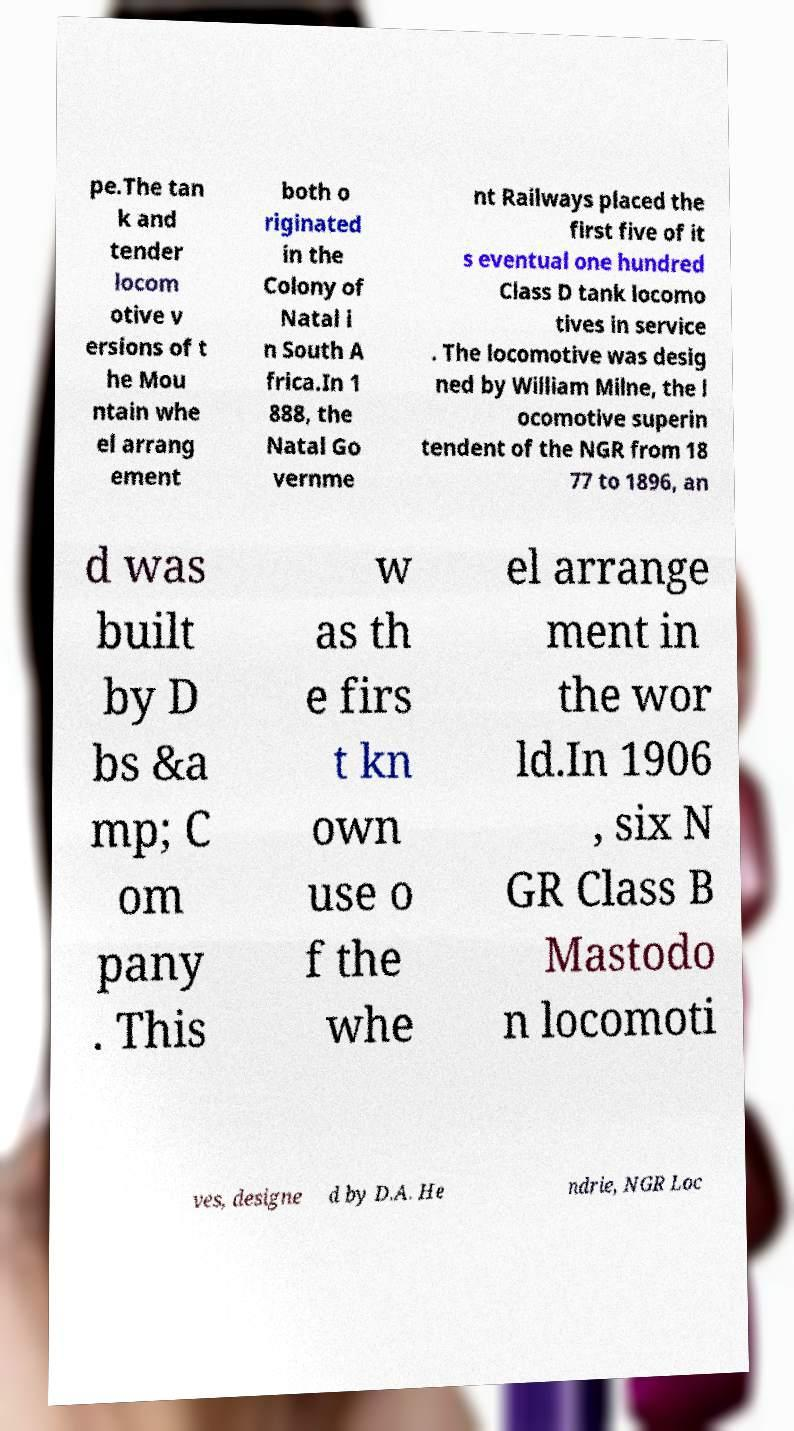Could you assist in decoding the text presented in this image and type it out clearly? pe.The tan k and tender locom otive v ersions of t he Mou ntain whe el arrang ement both o riginated in the Colony of Natal i n South A frica.In 1 888, the Natal Go vernme nt Railways placed the first five of it s eventual one hundred Class D tank locomo tives in service . The locomotive was desig ned by William Milne, the l ocomotive superin tendent of the NGR from 18 77 to 1896, an d was built by D bs &a mp; C om pany . This w as th e firs t kn own use o f the whe el arrange ment in the wor ld.In 1906 , six N GR Class B Mastodo n locomoti ves, designe d by D.A. He ndrie, NGR Loc 